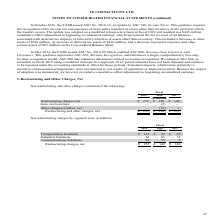According to Te Connectivity's financial document, What was the amount of Restructuring and Other Charges, Net in 2019? According to the financial document, $ 255 (in millions). The relevant text states: "Restructuring charges, net $ 255 $ 140 $ 146..." Also, For which years was the amount of Restructuring and Other Charges, Net calculated in? The document contains multiple relevant values: 2019, 2018, 2017. From the document: "2019 2018 2017 2019 2018 2017 2019 2018 2017..." Also, What are the components considered under Restructuring and Other Charges, Net? The document contains multiple relevant values: Restructuring charges, net, Gain on divestiture, Other charges (credits), net. From the document: "Other charges (credits), net — (12) 1 Restructuring charges, net $ 255 $ 140 $ 146 Gain on divestiture — (2) —..." Additionally, In which year was Restructuring charges, net the lowest? According to the financial document, 2018. The relevant text states: "2019 2018 2017..." Also, can you calculate: What was the change in Restructuring charges, net in 2019 from 2018? Based on the calculation: 255-140, the result is 115 (in millions). This is based on the information: "Restructuring charges, net $ 255 $ 140 $ 146 Restructuring charges, net $ 255 $ 140 $ 146..." The key data points involved are: 140, 255. Also, can you calculate: What was the percentage change in Restructuring charges, net in 2019 from 2018? To answer this question, I need to perform calculations using the financial data. The calculation is: (255-140)/140, which equals 82.14 (percentage). This is based on the information: "Restructuring charges, net $ 255 $ 140 $ 146 Restructuring charges, net $ 255 $ 140 $ 146..." The key data points involved are: 140, 255. 